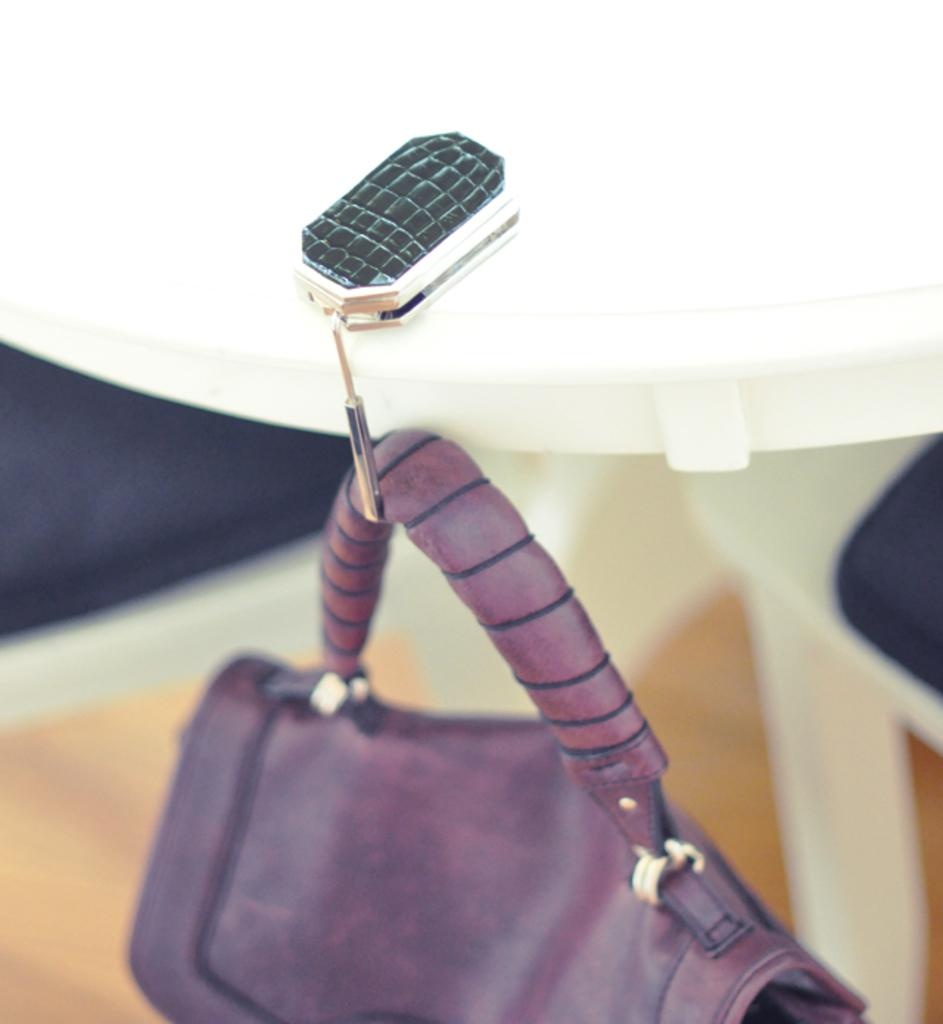What is hanging by a hook in the image? There is a purple color bag hanging by a hook in the image. What can be seen on the left side of the image? There is a chair on the left side of the image. What is present on the right side of the image? There is another chair on the right side of the image. What type of rhythm does the owl on the chair exhibit in the image? There is no owl present in the image, so it is not possible to determine any rhythm it might exhibit. 